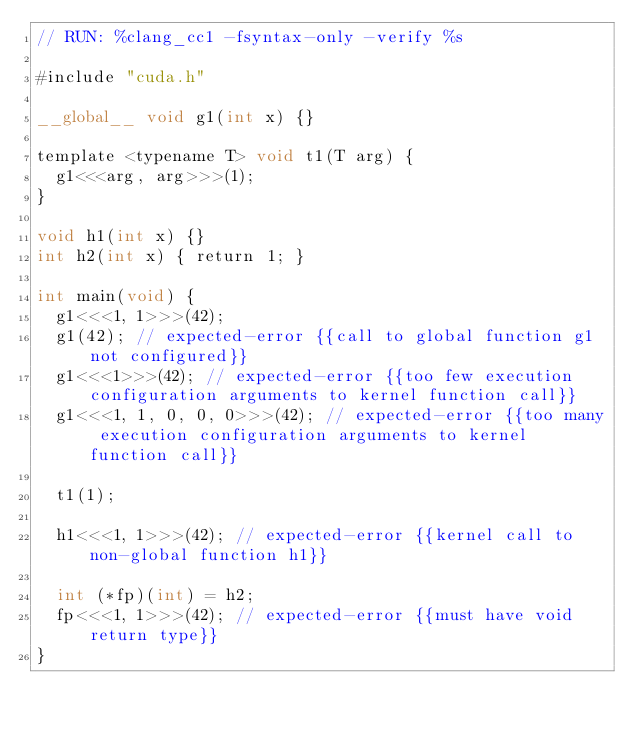<code> <loc_0><loc_0><loc_500><loc_500><_Cuda_>// RUN: %clang_cc1 -fsyntax-only -verify %s

#include "cuda.h"

__global__ void g1(int x) {}

template <typename T> void t1(T arg) {
  g1<<<arg, arg>>>(1);
}

void h1(int x) {}
int h2(int x) { return 1; }

int main(void) {
  g1<<<1, 1>>>(42);
  g1(42); // expected-error {{call to global function g1 not configured}}
  g1<<<1>>>(42); // expected-error {{too few execution configuration arguments to kernel function call}}
  g1<<<1, 1, 0, 0, 0>>>(42); // expected-error {{too many execution configuration arguments to kernel function call}}

  t1(1);

  h1<<<1, 1>>>(42); // expected-error {{kernel call to non-global function h1}}

  int (*fp)(int) = h2;
  fp<<<1, 1>>>(42); // expected-error {{must have void return type}}
}
</code> 